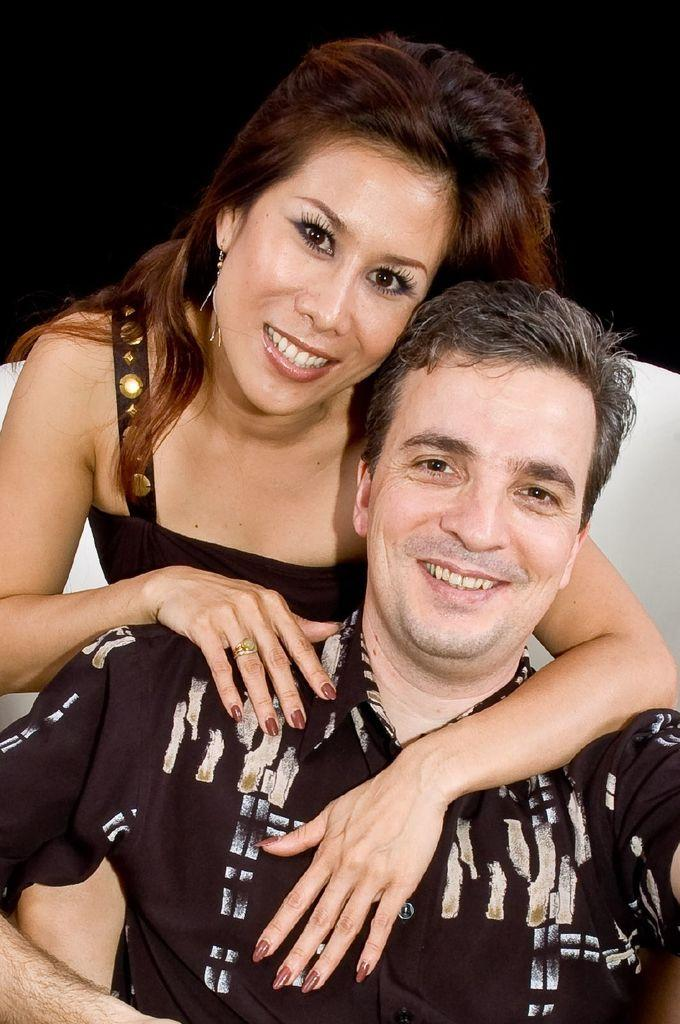How many people are in the image? There are two persons in the image. What are the two persons doing in the image? The two persons are sitting. What is the facial expression of the two persons in the image? The two persons are smiling. What type of leather is visible on the ground in the image? There is no leather visible on the ground in the image. What is the name of the person sitting on the left in the image? The provided facts do not include any names, so it is not possible to answer this question. 